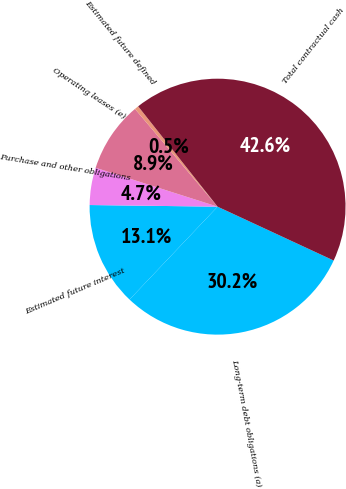Convert chart to OTSL. <chart><loc_0><loc_0><loc_500><loc_500><pie_chart><fcel>Long-term debt obligations (a)<fcel>Estimated future interest<fcel>Purchase and other obligations<fcel>Operating leases (e)<fcel>Estimated future defined<fcel>Total contractual cash<nl><fcel>30.16%<fcel>13.13%<fcel>4.71%<fcel>8.92%<fcel>0.51%<fcel>42.57%<nl></chart> 